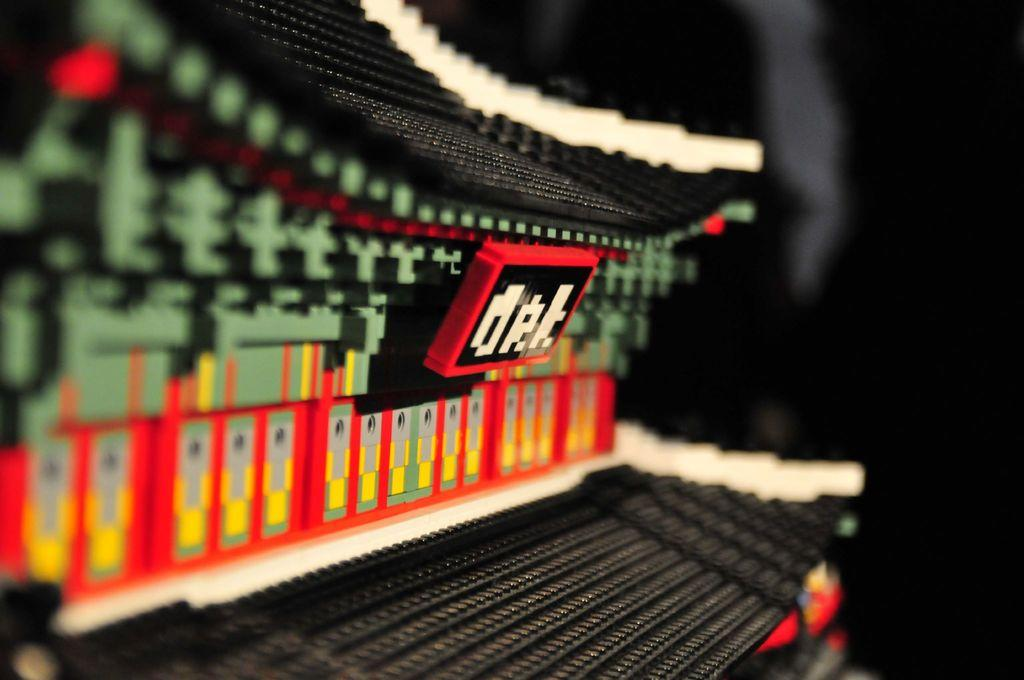What objects are present in the image? There are building blocks in the image. What can be observed about the background of the image? The background of the image is dark. How many grapes are visible on the building blocks in the image? There are no grapes present in the image; it only features building blocks. Can you describe the kicking motion of the elbow in the image? There is no kicking motion or elbow present in the image. 